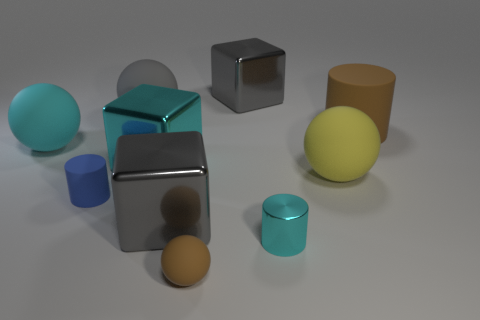Is the shape of the brown matte thing in front of the small cyan cylinder the same as the brown rubber thing that is on the right side of the small shiny object?
Provide a short and direct response. No. Is the number of large gray metallic blocks in front of the big brown rubber cylinder the same as the number of objects to the left of the blue cylinder?
Provide a short and direct response. Yes. What shape is the big gray metal thing behind the brown thing that is to the right of the small cylinder right of the tiny brown rubber object?
Your answer should be very brief. Cube. Are the tiny cylinder that is behind the cyan cylinder and the big thing that is right of the yellow matte object made of the same material?
Ensure brevity in your answer.  Yes. What shape is the large gray thing in front of the large brown cylinder?
Your response must be concise. Cube. Are there fewer small rubber cylinders than brown matte objects?
Provide a succinct answer. Yes. There is a metal cube that is on the right side of the sphere that is in front of the yellow rubber sphere; are there any large blocks in front of it?
Give a very brief answer. Yes. How many metal objects are big brown cylinders or large gray cylinders?
Your response must be concise. 0. Does the tiny rubber cylinder have the same color as the large cylinder?
Provide a succinct answer. No. There is a small cyan metal object; what number of tiny blue cylinders are behind it?
Provide a succinct answer. 1. 